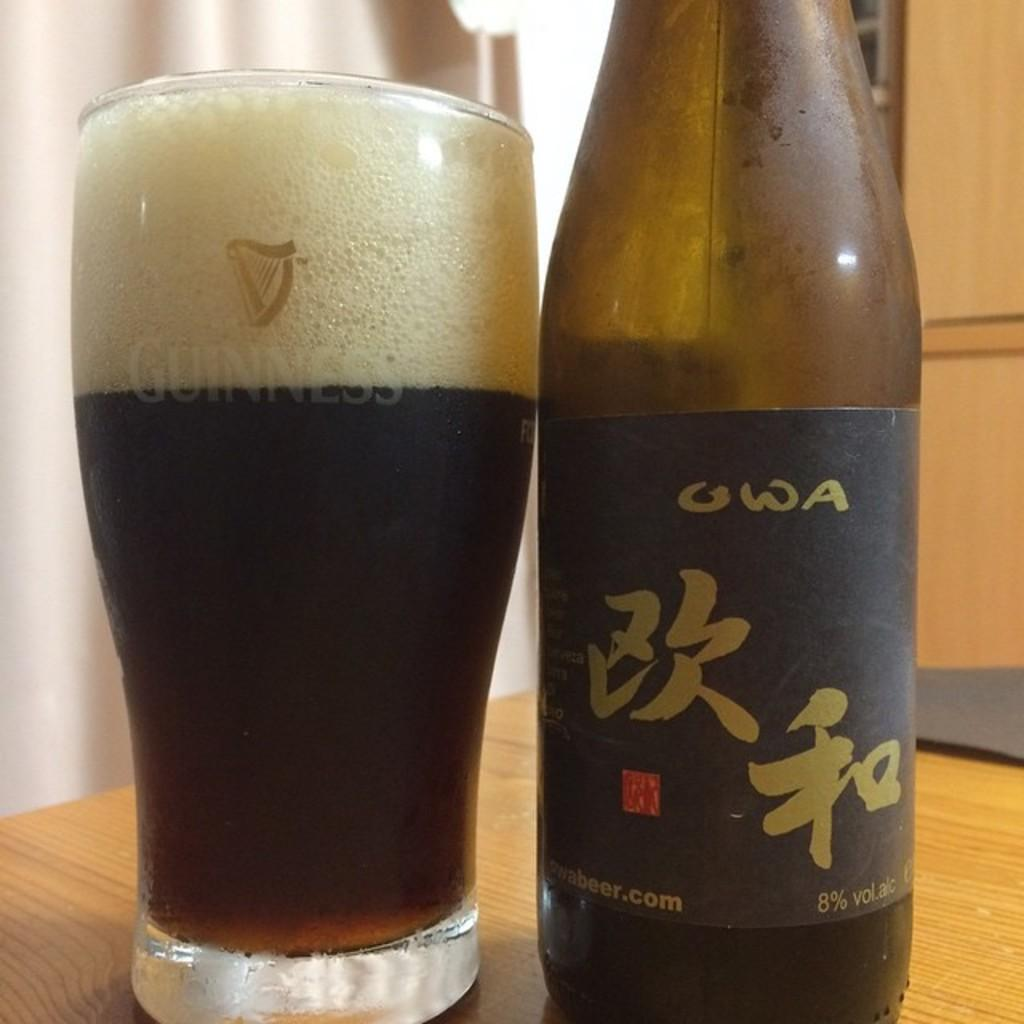Provide a one-sentence caption for the provided image. A bottle of OWA sits next to a full glass that says Guinness on it. 